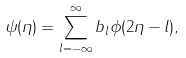Convert formula to latex. <formula><loc_0><loc_0><loc_500><loc_500>\psi ( \eta ) = \sum _ { l = - \infty } ^ { \infty } b _ { l } \phi ( 2 \eta - l ) ,</formula> 